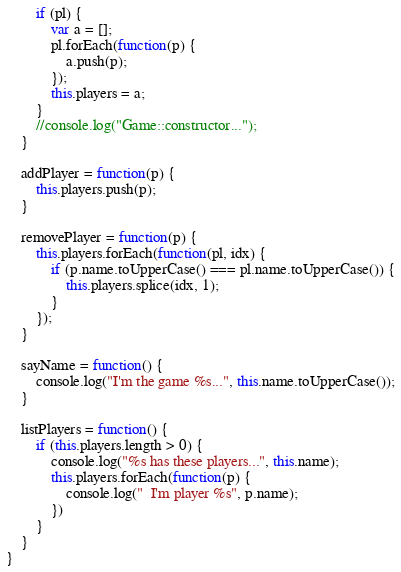Convert code to text. <code><loc_0><loc_0><loc_500><loc_500><_TypeScript_>        if (pl) {
            var a = [];
            pl.forEach(function(p) {
                a.push(p);
            });
            this.players = a;
        }
        //console.log("Game::constructor...");
    }
    
    addPlayer = function(p) {
        this.players.push(p);
    }
    
    removePlayer = function(p) {
        this.players.forEach(function(pl, idx) {
            if (p.name.toUpperCase() === pl.name.toUpperCase()) {
                this.players.splice(idx, 1);
            }
        });
    }
    
    sayName = function() {
        console.log("I'm the game %s...", this.name.toUpperCase());
    }
    
    listPlayers = function() {
        if (this.players.length > 0) {
            console.log("%s has these players...", this.name);
            this.players.forEach(function(p) {
                console.log("  I'm player %s", p.name);
            })
        }
    }
}</code> 